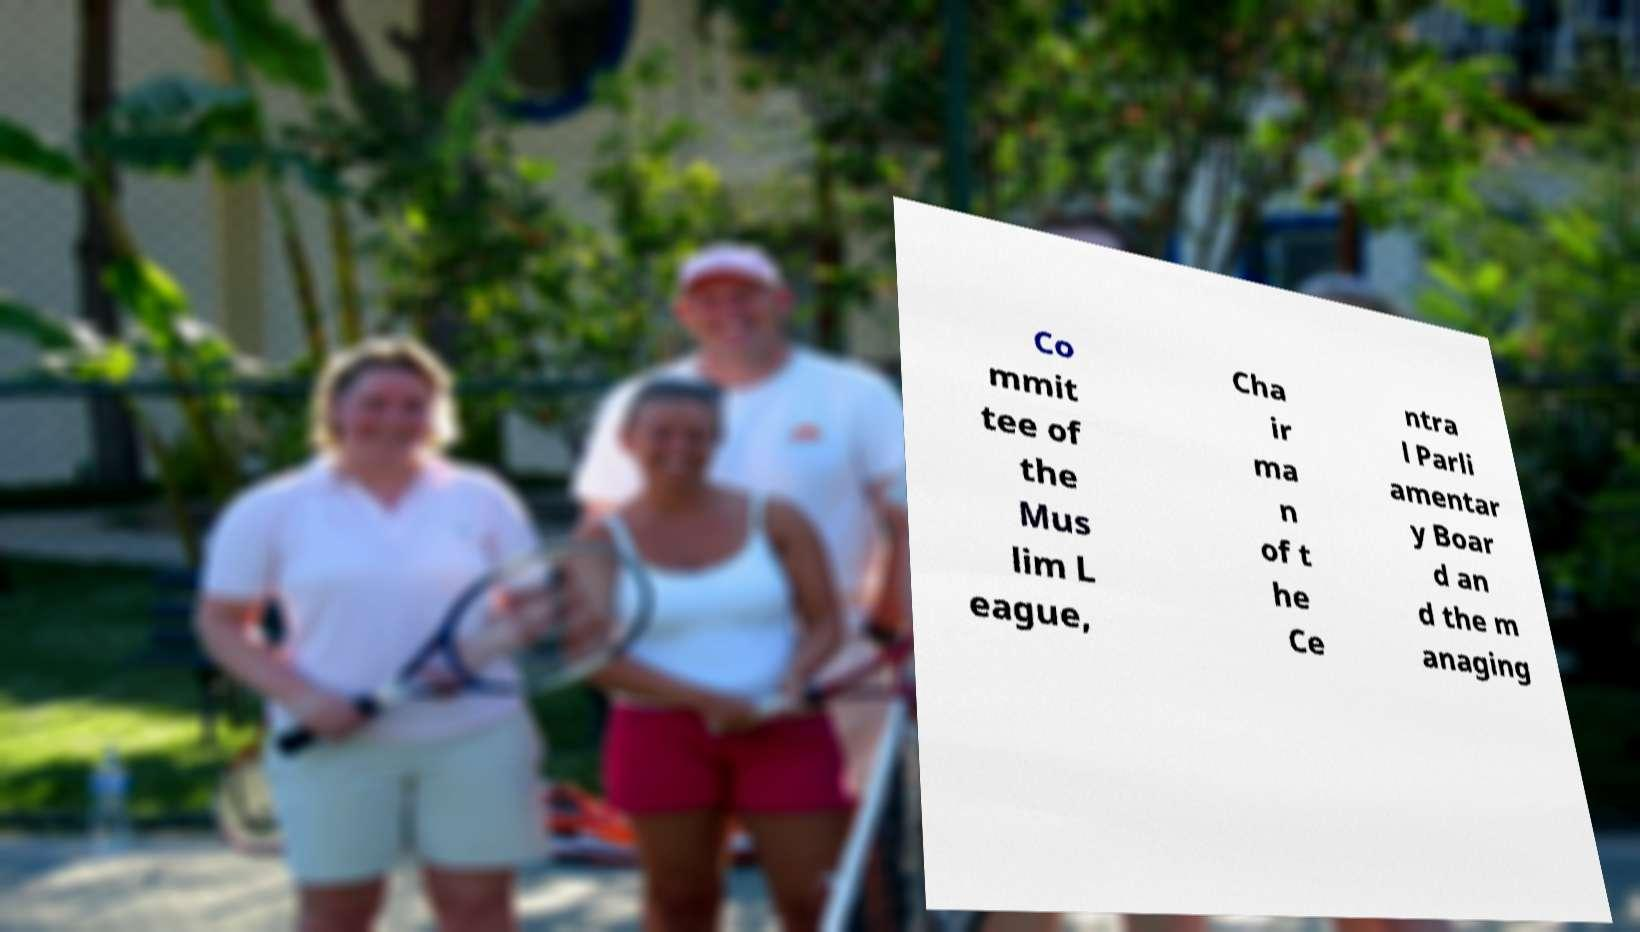Could you extract and type out the text from this image? Co mmit tee of the Mus lim L eague, Cha ir ma n of t he Ce ntra l Parli amentar y Boar d an d the m anaging 